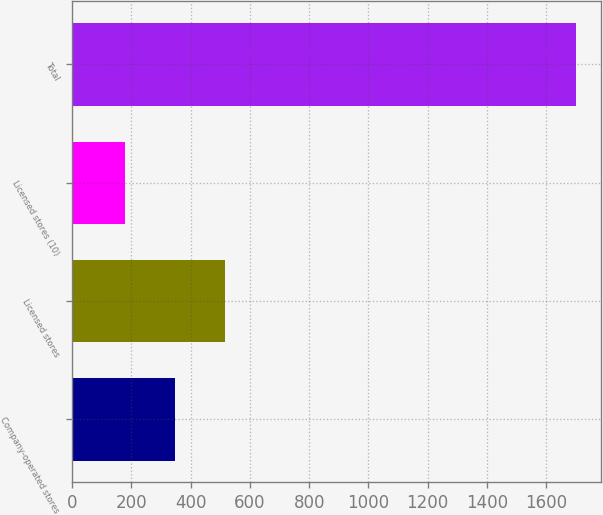Convert chart to OTSL. <chart><loc_0><loc_0><loc_500><loc_500><bar_chart><fcel>Company-operated stores<fcel>Licensed stores<fcel>Licensed stores (10)<fcel>Total<nl><fcel>348.2<fcel>517.3<fcel>179.1<fcel>1701<nl></chart> 